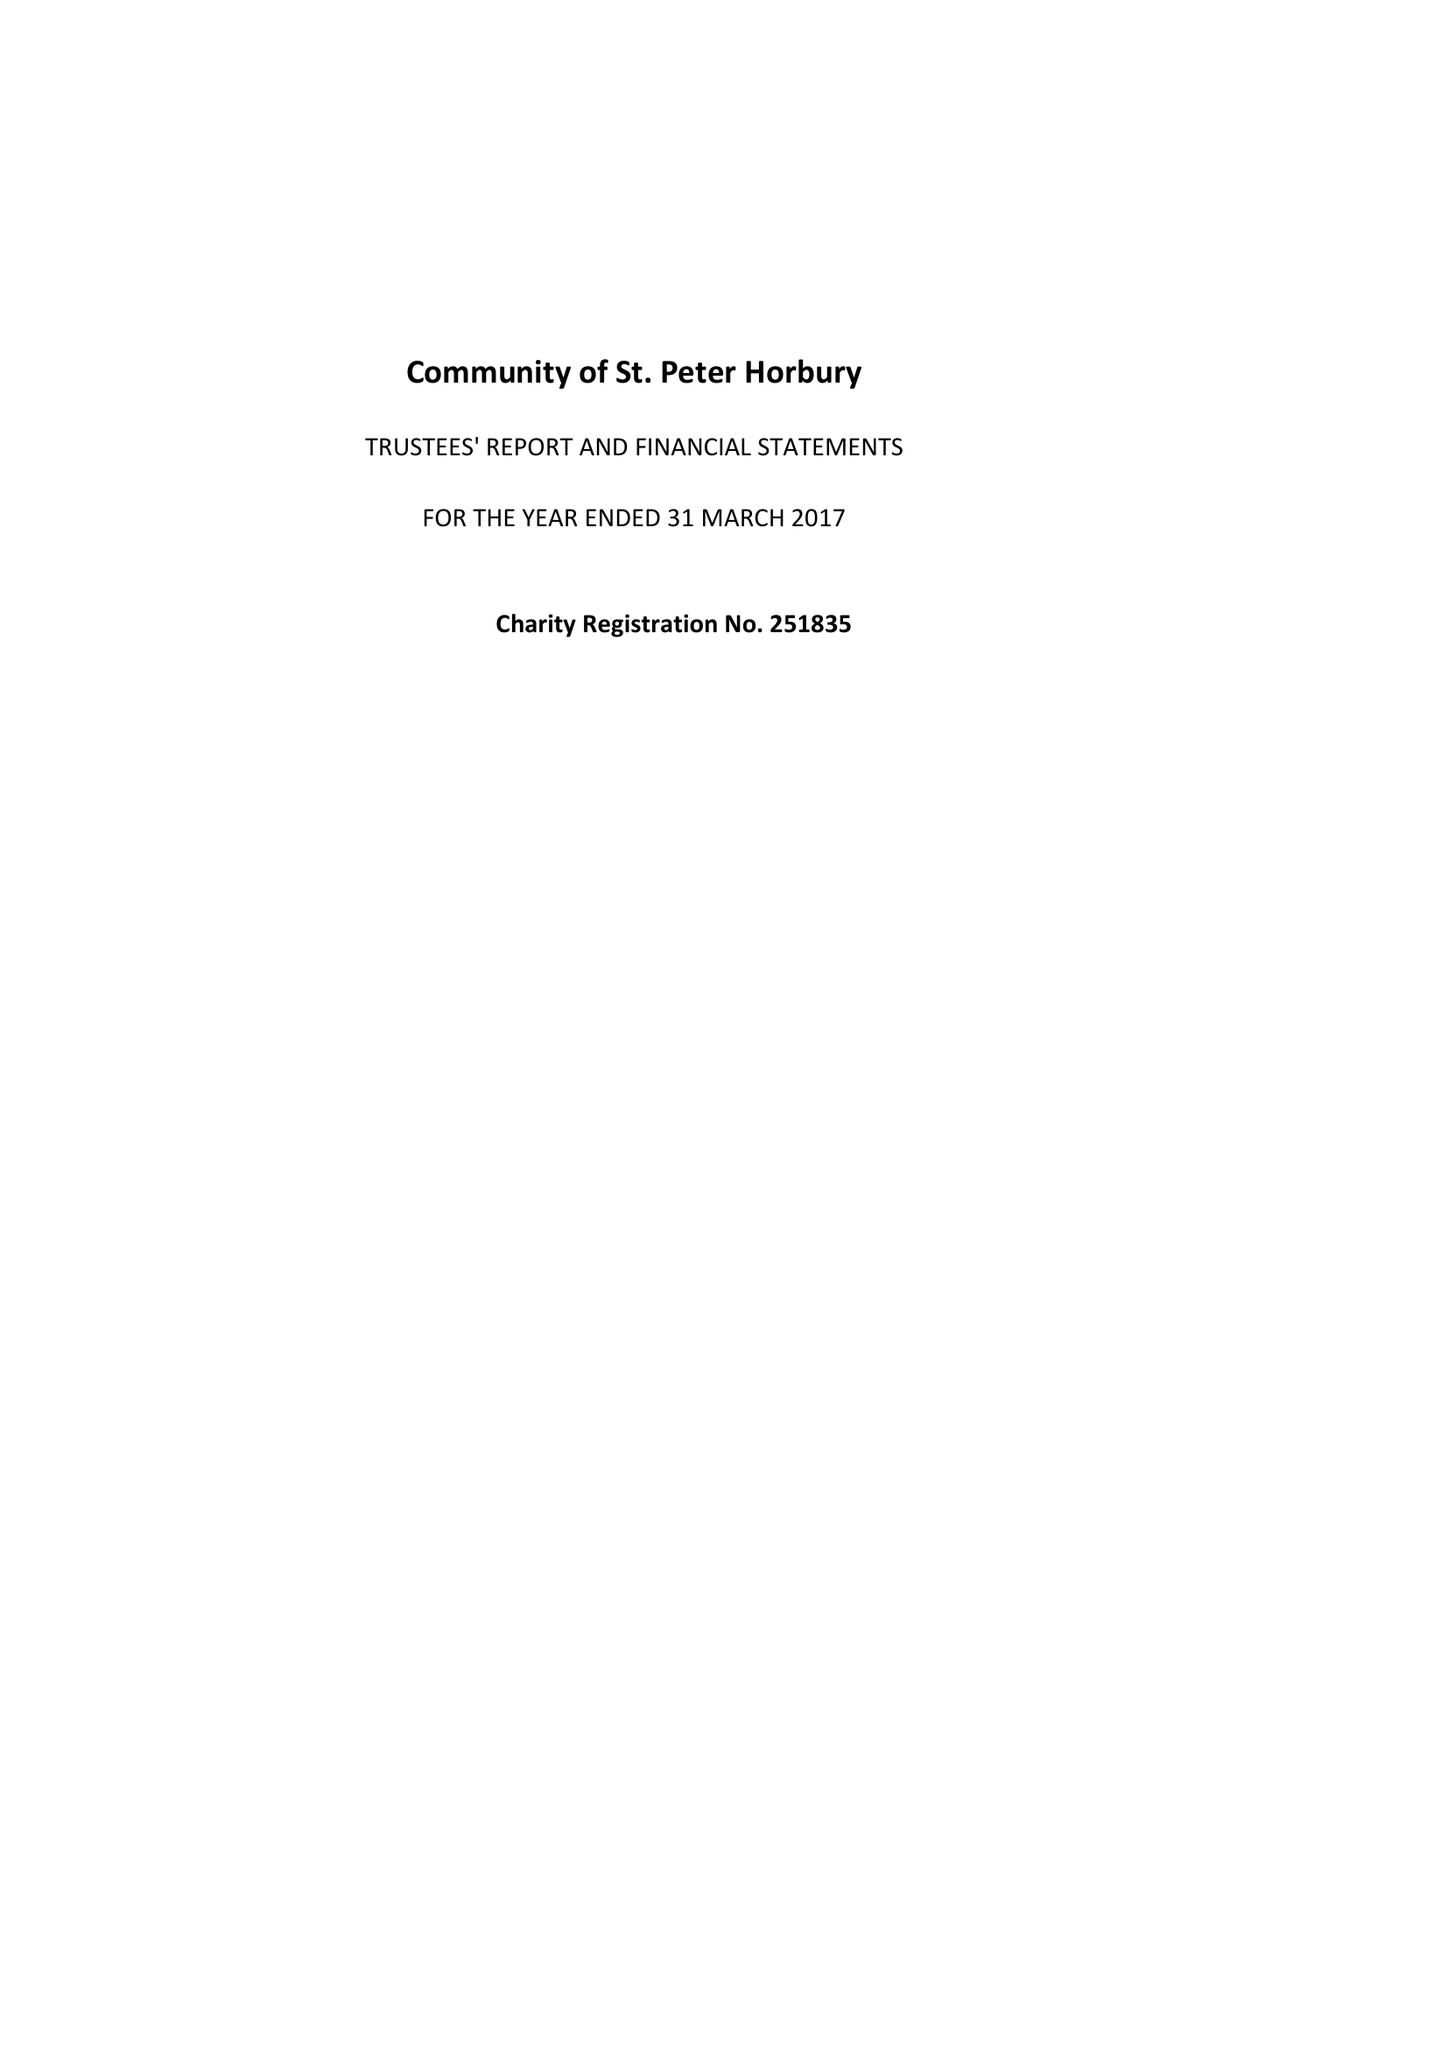What is the value for the spending_annually_in_british_pounds?
Answer the question using a single word or phrase. 179980.00 